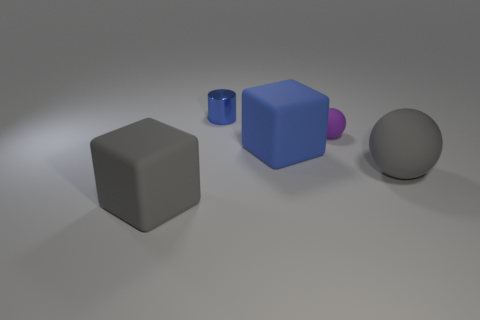Are there any other things that are made of the same material as the tiny cylinder?
Provide a short and direct response. No. What number of other objects are there of the same size as the gray rubber block?
Offer a terse response. 2. Do the small cylinder and the small matte sphere have the same color?
Offer a terse response. No. What number of tiny purple balls are behind the matte block in front of the big gray thing that is on the right side of the purple object?
Give a very brief answer. 1. What material is the block behind the large thing that is left of the tiny shiny cylinder?
Make the answer very short. Rubber. Is there another blue thing that has the same shape as the small metal object?
Keep it short and to the point. No. What color is the matte sphere that is the same size as the cylinder?
Provide a succinct answer. Purple. What number of things are either things that are on the left side of the large blue matte object or big rubber things left of the tiny rubber ball?
Your response must be concise. 3. What number of things are large cyan cubes or spheres?
Provide a short and direct response. 2. What is the size of the object that is behind the big blue rubber object and on the left side of the tiny purple thing?
Give a very brief answer. Small. 